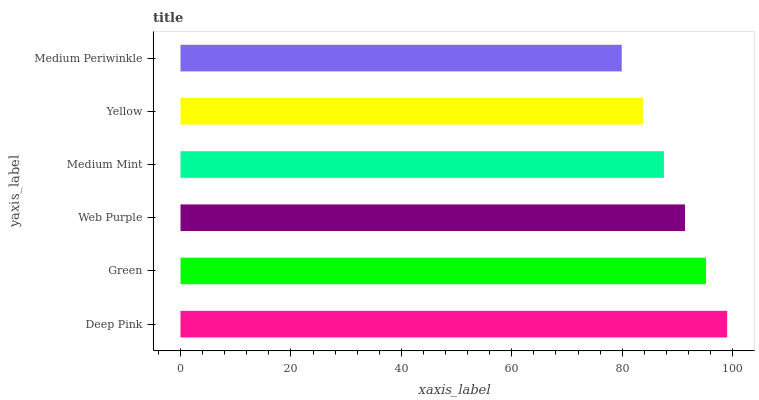Is Medium Periwinkle the minimum?
Answer yes or no. Yes. Is Deep Pink the maximum?
Answer yes or no. Yes. Is Green the minimum?
Answer yes or no. No. Is Green the maximum?
Answer yes or no. No. Is Deep Pink greater than Green?
Answer yes or no. Yes. Is Green less than Deep Pink?
Answer yes or no. Yes. Is Green greater than Deep Pink?
Answer yes or no. No. Is Deep Pink less than Green?
Answer yes or no. No. Is Web Purple the high median?
Answer yes or no. Yes. Is Medium Mint the low median?
Answer yes or no. Yes. Is Deep Pink the high median?
Answer yes or no. No. Is Green the low median?
Answer yes or no. No. 